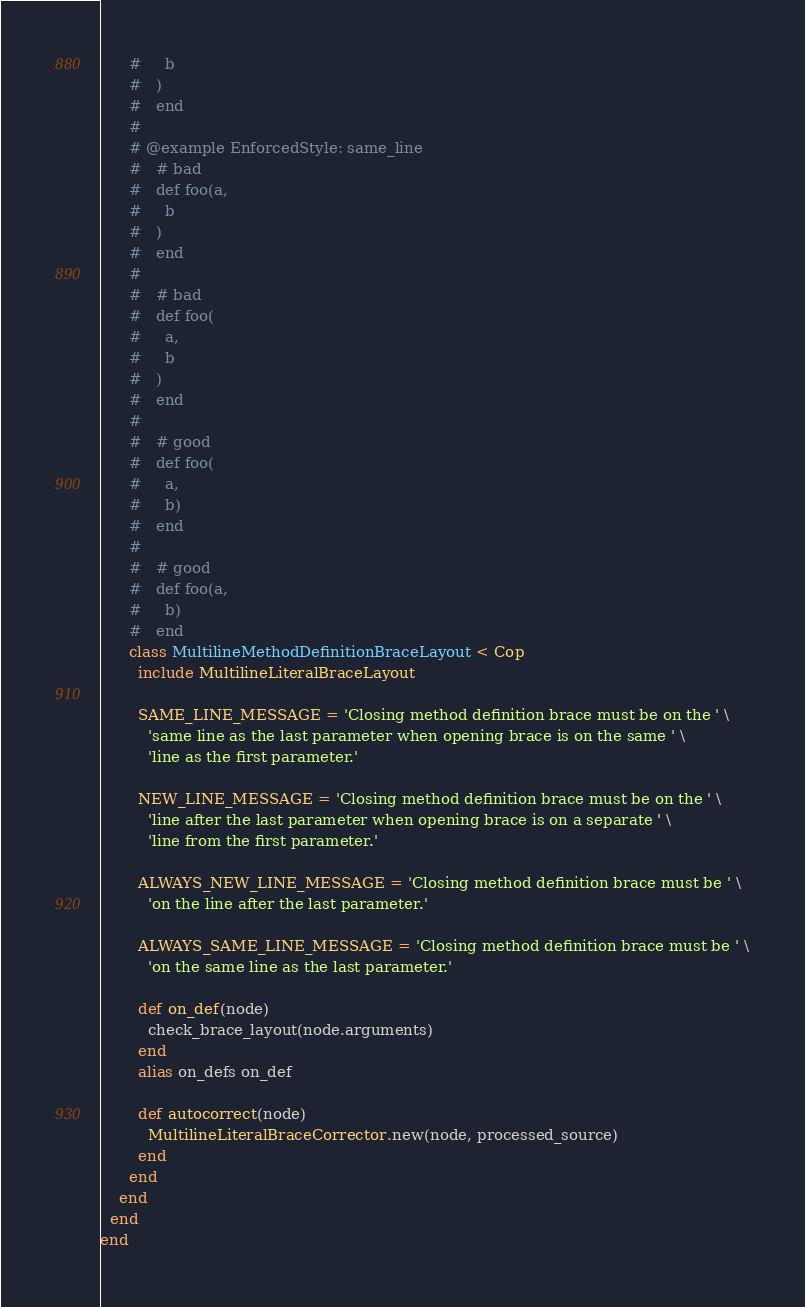<code> <loc_0><loc_0><loc_500><loc_500><_Ruby_>      #     b
      #   )
      #   end
      #
      # @example EnforcedStyle: same_line
      #   # bad
      #   def foo(a,
      #     b
      #   )
      #   end
      #
      #   # bad
      #   def foo(
      #     a,
      #     b
      #   )
      #   end
      #
      #   # good
      #   def foo(
      #     a,
      #     b)
      #   end
      #
      #   # good
      #   def foo(a,
      #     b)
      #   end
      class MultilineMethodDefinitionBraceLayout < Cop
        include MultilineLiteralBraceLayout

        SAME_LINE_MESSAGE = 'Closing method definition brace must be on the ' \
          'same line as the last parameter when opening brace is on the same ' \
          'line as the first parameter.'

        NEW_LINE_MESSAGE = 'Closing method definition brace must be on the ' \
          'line after the last parameter when opening brace is on a separate ' \
          'line from the first parameter.'

        ALWAYS_NEW_LINE_MESSAGE = 'Closing method definition brace must be ' \
          'on the line after the last parameter.'

        ALWAYS_SAME_LINE_MESSAGE = 'Closing method definition brace must be ' \
          'on the same line as the last parameter.'

        def on_def(node)
          check_brace_layout(node.arguments)
        end
        alias on_defs on_def

        def autocorrect(node)
          MultilineLiteralBraceCorrector.new(node, processed_source)
        end
      end
    end
  end
end
</code> 